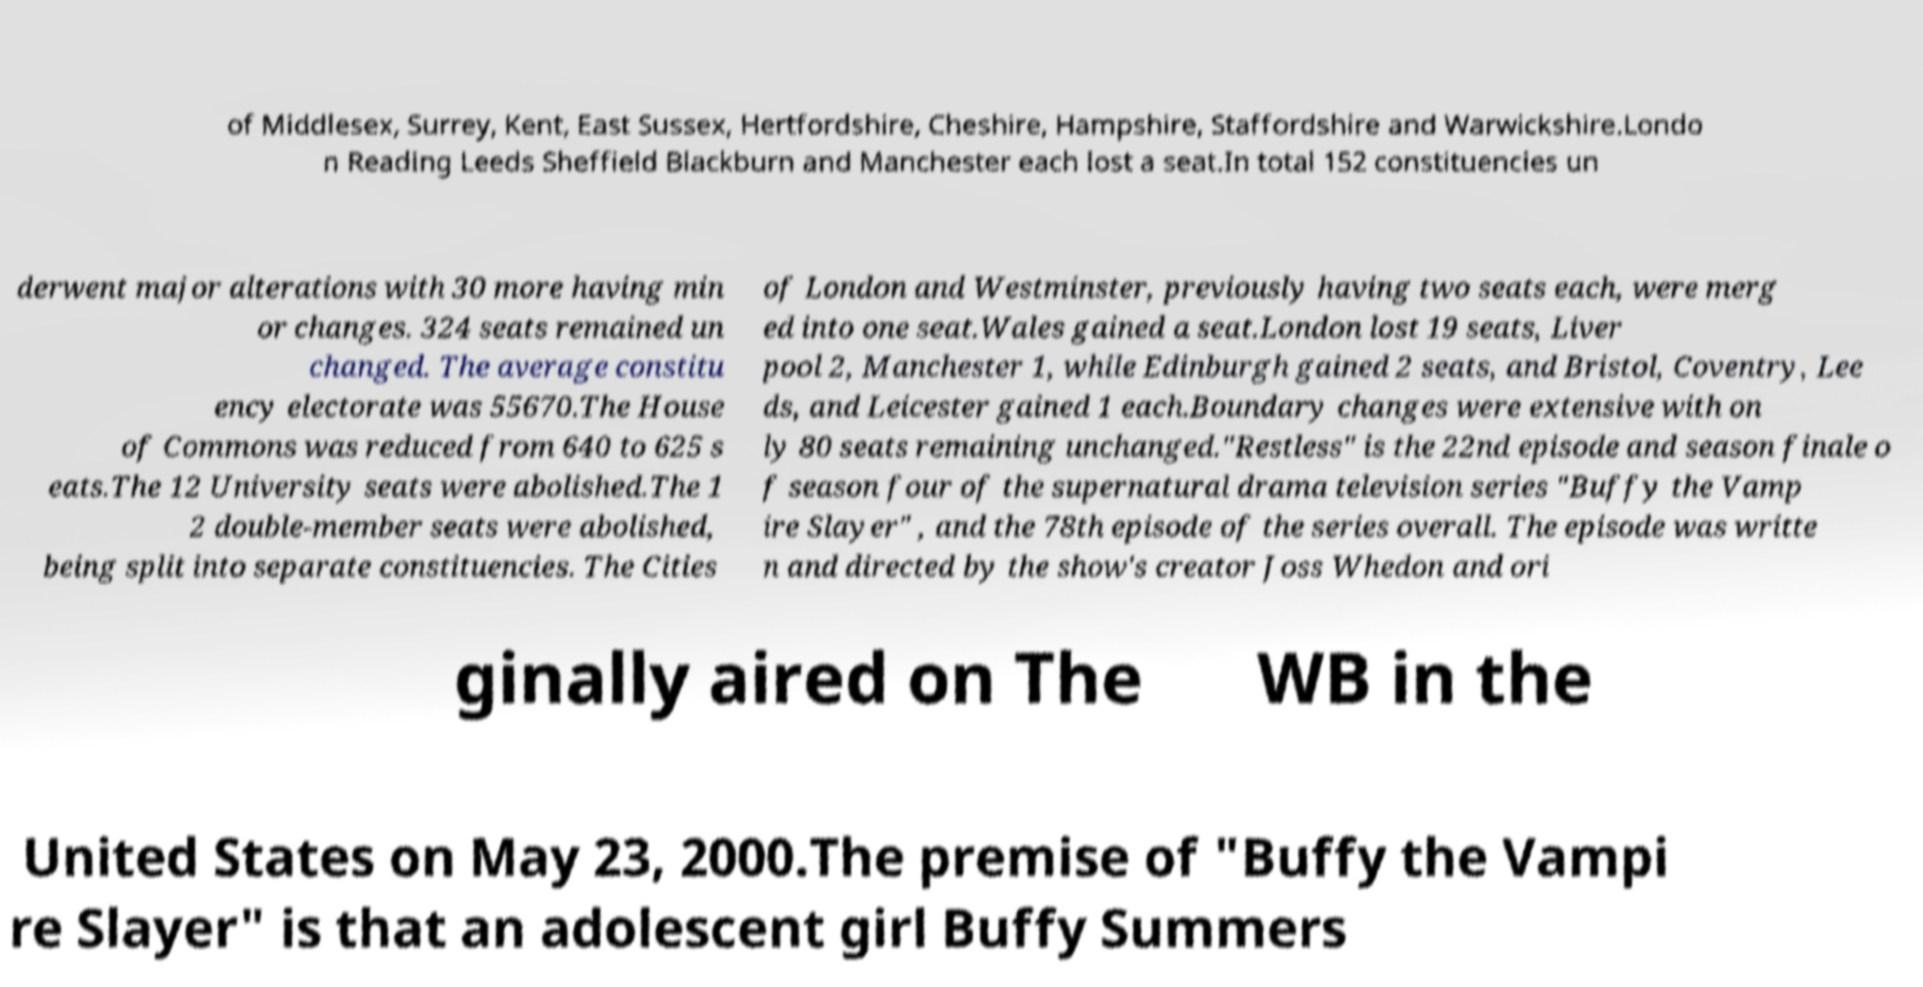Can you read and provide the text displayed in the image?This photo seems to have some interesting text. Can you extract and type it out for me? of Middlesex, Surrey, Kent, East Sussex, Hertfordshire, Cheshire, Hampshire, Staffordshire and Warwickshire.Londo n Reading Leeds Sheffield Blackburn and Manchester each lost a seat.In total 152 constituencies un derwent major alterations with 30 more having min or changes. 324 seats remained un changed. The average constitu ency electorate was 55670.The House of Commons was reduced from 640 to 625 s eats.The 12 University seats were abolished.The 1 2 double-member seats were abolished, being split into separate constituencies. The Cities of London and Westminster, previously having two seats each, were merg ed into one seat.Wales gained a seat.London lost 19 seats, Liver pool 2, Manchester 1, while Edinburgh gained 2 seats, and Bristol, Coventry, Lee ds, and Leicester gained 1 each.Boundary changes were extensive with on ly 80 seats remaining unchanged."Restless" is the 22nd episode and season finale o f season four of the supernatural drama television series "Buffy the Vamp ire Slayer" , and the 78th episode of the series overall. The episode was writte n and directed by the show's creator Joss Whedon and ori ginally aired on The WB in the United States on May 23, 2000.The premise of "Buffy the Vampi re Slayer" is that an adolescent girl Buffy Summers 